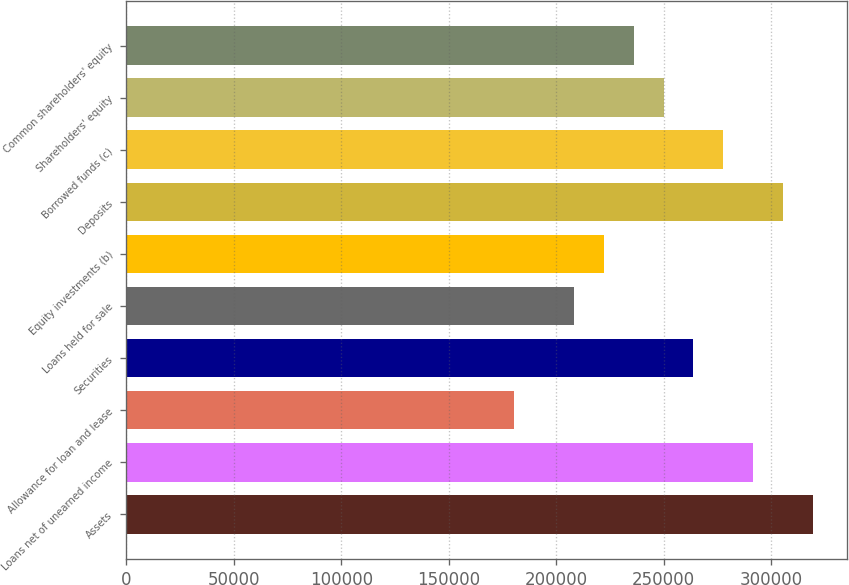Convert chart. <chart><loc_0><loc_0><loc_500><loc_500><bar_chart><fcel>Assets<fcel>Loans net of unearned income<fcel>Allowance for loan and lease<fcel>Securities<fcel>Loans held for sale<fcel>Equity investments (b)<fcel>Deposits<fcel>Borrowed funds (c)<fcel>Shareholders' equity<fcel>Common shareholders' equity<nl><fcel>319514<fcel>291731<fcel>180596<fcel>263947<fcel>208379<fcel>222271<fcel>305623<fcel>277839<fcel>250055<fcel>236163<nl></chart> 